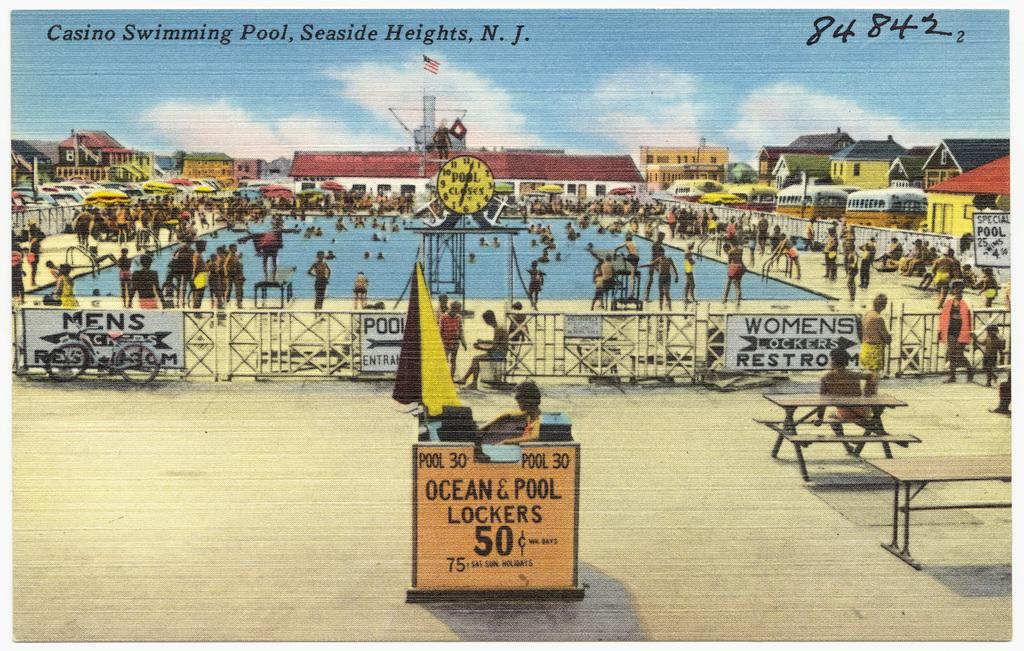<image>
Write a terse but informative summary of the picture. A post card of a pool area that is titled Casino Swimming Pool, Seaside Heights NJ 